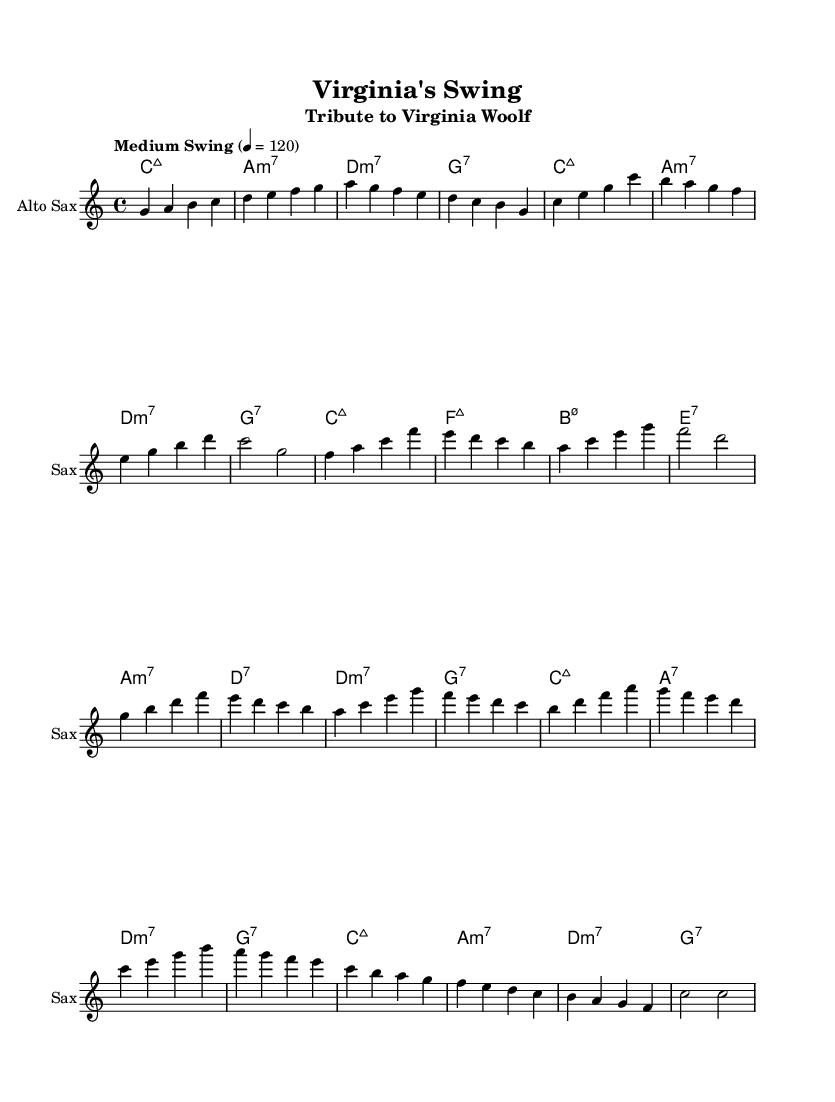What is the key signature of this music? The key signature is C major, which has no sharps or flats.
Answer: C major What is the time signature of this music? The time signature is indicated at the beginning, which is 4/4, meaning there are four beats in each measure.
Answer: 4/4 What is the tempo marking of this piece? The tempo marking is "Medium Swing," which gives an idea about the character and speed of the music.
Answer: Medium Swing What is the final chord in the music? The final chord can be identified at the end of the sheet music; it is marked as a C major 7 chord.
Answer: C:maj7 How many measures are in the A section? The A section consists of 16 bars total, which can be calculated by counting the measures specifically labeled as the A section.
Answer: 16 What is the starting note of the saxophone part? The first note of the saxophone melody is G, which is the first note in the introductory phrase.
Answer: G How many different chords are used in the B section? By analyzing the chord names in the B section, we can see there are eight different chords used throughout.
Answer: 8 